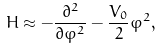<formula> <loc_0><loc_0><loc_500><loc_500>H \approx - \frac { \partial ^ { 2 } } { \partial \varphi ^ { 2 } } - \frac { V _ { 0 } } { 2 } \varphi ^ { 2 } ,</formula> 